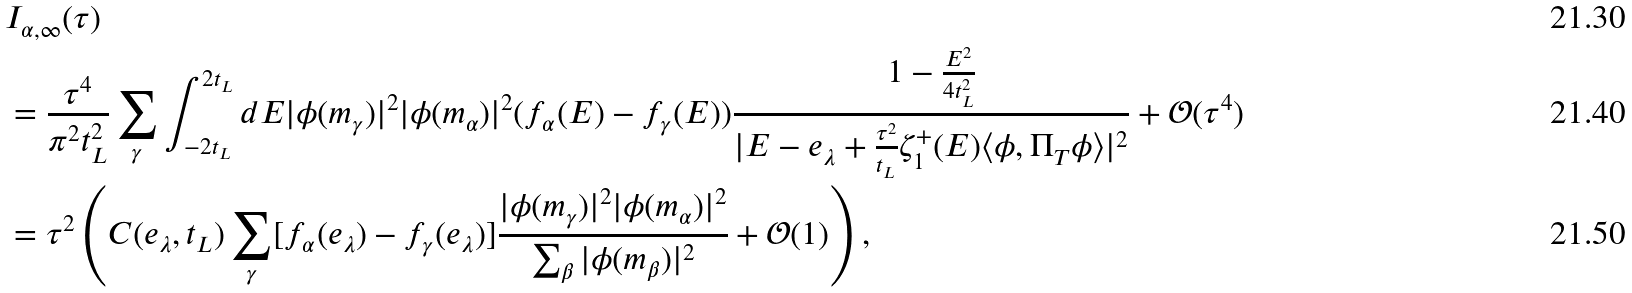<formula> <loc_0><loc_0><loc_500><loc_500>& I _ { \alpha , \infty } ( \tau ) \\ & = \frac { \tau ^ { 4 } } { \pi ^ { 2 } t _ { L } ^ { 2 } } \sum _ { \gamma } \int _ { - 2 t _ { L } } ^ { 2 t _ { L } } d E | \phi ( m _ { \gamma } ) | ^ { 2 } | \phi ( m _ { \alpha } ) | ^ { 2 } ( f _ { \alpha } ( E ) - f _ { \gamma } ( E ) ) \frac { 1 - \frac { E ^ { 2 } } { 4 t _ { L } ^ { 2 } } } { | E - e _ { \lambda } + \frac { \tau ^ { 2 } } { t _ { L } } \zeta _ { 1 } ^ { + } ( E ) \langle \phi , \Pi _ { T } \phi \rangle | ^ { 2 } } + \mathcal { O } ( \tau ^ { 4 } ) \\ & = \tau ^ { 2 } \left ( C ( e _ { \lambda } , t _ { L } ) \sum _ { \gamma } [ f _ { \alpha } ( e _ { \lambda } ) - f _ { \gamma } ( e _ { \lambda } ) ] \frac { | \phi ( m _ { \gamma } ) | ^ { 2 } | \phi ( m _ { \alpha } ) | ^ { 2 } } { \sum _ { \beta } | \phi ( m _ { \beta } ) | ^ { 2 } } + \mathcal { O } ( 1 ) \right ) ,</formula> 